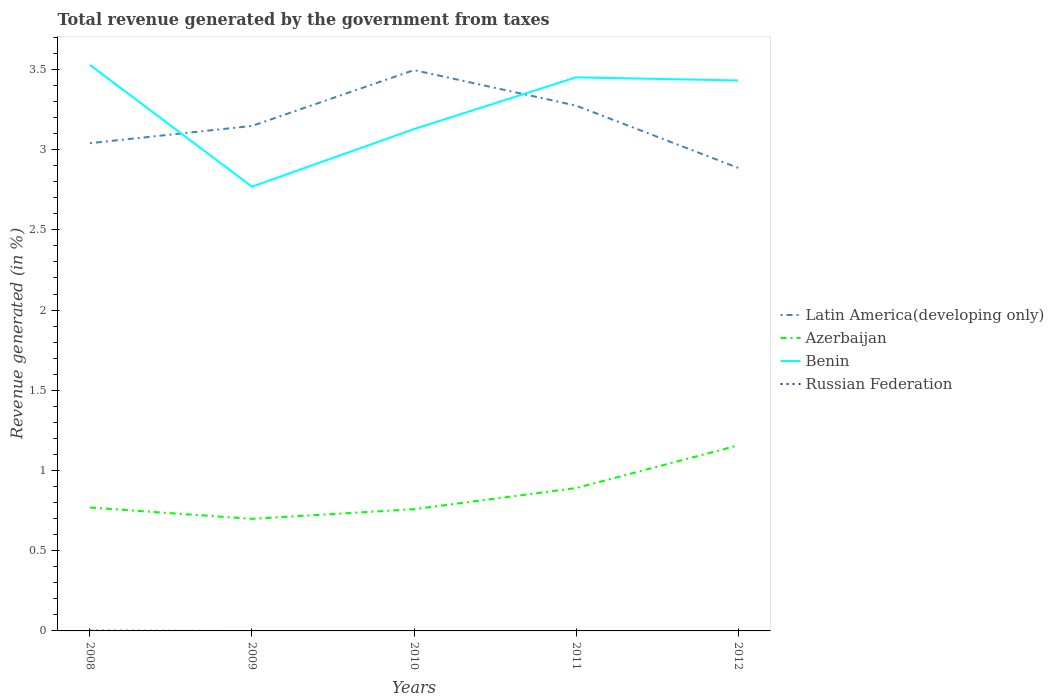How many different coloured lines are there?
Offer a very short reply. 4. Does the line corresponding to Latin America(developing only) intersect with the line corresponding to Russian Federation?
Your response must be concise. No. Is the number of lines equal to the number of legend labels?
Your answer should be compact. No. Across all years, what is the maximum total revenue generated in Azerbaijan?
Make the answer very short. 0.7. What is the total total revenue generated in Benin in the graph?
Make the answer very short. -0.66. What is the difference between the highest and the second highest total revenue generated in Azerbaijan?
Your response must be concise. 0.46. What is the difference between the highest and the lowest total revenue generated in Russian Federation?
Offer a very short reply. 1. How many lines are there?
Provide a short and direct response. 4. Are the values on the major ticks of Y-axis written in scientific E-notation?
Offer a terse response. No. Does the graph contain any zero values?
Provide a succinct answer. Yes. Where does the legend appear in the graph?
Give a very brief answer. Center right. How are the legend labels stacked?
Your response must be concise. Vertical. What is the title of the graph?
Your answer should be very brief. Total revenue generated by the government from taxes. Does "Malta" appear as one of the legend labels in the graph?
Keep it short and to the point. No. What is the label or title of the X-axis?
Your answer should be compact. Years. What is the label or title of the Y-axis?
Make the answer very short. Revenue generated (in %). What is the Revenue generated (in %) in Latin America(developing only) in 2008?
Keep it short and to the point. 3.04. What is the Revenue generated (in %) in Azerbaijan in 2008?
Your answer should be compact. 0.77. What is the Revenue generated (in %) in Benin in 2008?
Provide a short and direct response. 3.53. What is the Revenue generated (in %) in Russian Federation in 2008?
Your answer should be very brief. 0. What is the Revenue generated (in %) in Latin America(developing only) in 2009?
Ensure brevity in your answer.  3.15. What is the Revenue generated (in %) of Azerbaijan in 2009?
Make the answer very short. 0.7. What is the Revenue generated (in %) in Benin in 2009?
Provide a short and direct response. 2.77. What is the Revenue generated (in %) in Latin America(developing only) in 2010?
Make the answer very short. 3.5. What is the Revenue generated (in %) in Azerbaijan in 2010?
Provide a succinct answer. 0.76. What is the Revenue generated (in %) in Benin in 2010?
Provide a short and direct response. 3.13. What is the Revenue generated (in %) of Russian Federation in 2010?
Your answer should be compact. 0. What is the Revenue generated (in %) of Latin America(developing only) in 2011?
Make the answer very short. 3.27. What is the Revenue generated (in %) in Azerbaijan in 2011?
Your answer should be compact. 0.89. What is the Revenue generated (in %) in Benin in 2011?
Your answer should be compact. 3.45. What is the Revenue generated (in %) in Latin America(developing only) in 2012?
Make the answer very short. 2.89. What is the Revenue generated (in %) in Azerbaijan in 2012?
Give a very brief answer. 1.16. What is the Revenue generated (in %) in Benin in 2012?
Offer a terse response. 3.43. Across all years, what is the maximum Revenue generated (in %) of Latin America(developing only)?
Give a very brief answer. 3.5. Across all years, what is the maximum Revenue generated (in %) of Azerbaijan?
Provide a short and direct response. 1.16. Across all years, what is the maximum Revenue generated (in %) in Benin?
Ensure brevity in your answer.  3.53. Across all years, what is the maximum Revenue generated (in %) in Russian Federation?
Your answer should be compact. 0. Across all years, what is the minimum Revenue generated (in %) of Latin America(developing only)?
Offer a terse response. 2.89. Across all years, what is the minimum Revenue generated (in %) in Azerbaijan?
Provide a short and direct response. 0.7. Across all years, what is the minimum Revenue generated (in %) in Benin?
Your response must be concise. 2.77. Across all years, what is the minimum Revenue generated (in %) of Russian Federation?
Make the answer very short. 0. What is the total Revenue generated (in %) of Latin America(developing only) in the graph?
Keep it short and to the point. 15.84. What is the total Revenue generated (in %) of Azerbaijan in the graph?
Your answer should be compact. 4.27. What is the total Revenue generated (in %) of Benin in the graph?
Your answer should be compact. 16.31. What is the total Revenue generated (in %) of Russian Federation in the graph?
Provide a short and direct response. 0. What is the difference between the Revenue generated (in %) of Latin America(developing only) in 2008 and that in 2009?
Your response must be concise. -0.11. What is the difference between the Revenue generated (in %) of Azerbaijan in 2008 and that in 2009?
Give a very brief answer. 0.07. What is the difference between the Revenue generated (in %) of Benin in 2008 and that in 2009?
Offer a terse response. 0.76. What is the difference between the Revenue generated (in %) in Latin America(developing only) in 2008 and that in 2010?
Your answer should be compact. -0.46. What is the difference between the Revenue generated (in %) in Azerbaijan in 2008 and that in 2010?
Your answer should be compact. 0.01. What is the difference between the Revenue generated (in %) of Benin in 2008 and that in 2010?
Your answer should be compact. 0.4. What is the difference between the Revenue generated (in %) of Latin America(developing only) in 2008 and that in 2011?
Your response must be concise. -0.23. What is the difference between the Revenue generated (in %) in Azerbaijan in 2008 and that in 2011?
Offer a very short reply. -0.12. What is the difference between the Revenue generated (in %) in Benin in 2008 and that in 2011?
Your answer should be compact. 0.08. What is the difference between the Revenue generated (in %) in Latin America(developing only) in 2008 and that in 2012?
Provide a succinct answer. 0.15. What is the difference between the Revenue generated (in %) of Azerbaijan in 2008 and that in 2012?
Ensure brevity in your answer.  -0.39. What is the difference between the Revenue generated (in %) in Benin in 2008 and that in 2012?
Provide a short and direct response. 0.1. What is the difference between the Revenue generated (in %) in Latin America(developing only) in 2009 and that in 2010?
Provide a short and direct response. -0.35. What is the difference between the Revenue generated (in %) in Azerbaijan in 2009 and that in 2010?
Ensure brevity in your answer.  -0.06. What is the difference between the Revenue generated (in %) of Benin in 2009 and that in 2010?
Give a very brief answer. -0.36. What is the difference between the Revenue generated (in %) in Latin America(developing only) in 2009 and that in 2011?
Provide a succinct answer. -0.13. What is the difference between the Revenue generated (in %) of Azerbaijan in 2009 and that in 2011?
Your answer should be very brief. -0.19. What is the difference between the Revenue generated (in %) of Benin in 2009 and that in 2011?
Keep it short and to the point. -0.68. What is the difference between the Revenue generated (in %) of Latin America(developing only) in 2009 and that in 2012?
Your answer should be very brief. 0.26. What is the difference between the Revenue generated (in %) in Azerbaijan in 2009 and that in 2012?
Provide a succinct answer. -0.46. What is the difference between the Revenue generated (in %) in Benin in 2009 and that in 2012?
Offer a terse response. -0.66. What is the difference between the Revenue generated (in %) in Latin America(developing only) in 2010 and that in 2011?
Provide a succinct answer. 0.22. What is the difference between the Revenue generated (in %) in Azerbaijan in 2010 and that in 2011?
Your response must be concise. -0.13. What is the difference between the Revenue generated (in %) in Benin in 2010 and that in 2011?
Your response must be concise. -0.32. What is the difference between the Revenue generated (in %) of Latin America(developing only) in 2010 and that in 2012?
Ensure brevity in your answer.  0.61. What is the difference between the Revenue generated (in %) in Azerbaijan in 2010 and that in 2012?
Keep it short and to the point. -0.4. What is the difference between the Revenue generated (in %) in Benin in 2010 and that in 2012?
Your answer should be compact. -0.3. What is the difference between the Revenue generated (in %) of Latin America(developing only) in 2011 and that in 2012?
Offer a terse response. 0.39. What is the difference between the Revenue generated (in %) in Azerbaijan in 2011 and that in 2012?
Your answer should be compact. -0.27. What is the difference between the Revenue generated (in %) in Benin in 2011 and that in 2012?
Make the answer very short. 0.02. What is the difference between the Revenue generated (in %) in Latin America(developing only) in 2008 and the Revenue generated (in %) in Azerbaijan in 2009?
Provide a short and direct response. 2.34. What is the difference between the Revenue generated (in %) of Latin America(developing only) in 2008 and the Revenue generated (in %) of Benin in 2009?
Keep it short and to the point. 0.27. What is the difference between the Revenue generated (in %) of Azerbaijan in 2008 and the Revenue generated (in %) of Benin in 2009?
Your answer should be very brief. -2. What is the difference between the Revenue generated (in %) in Latin America(developing only) in 2008 and the Revenue generated (in %) in Azerbaijan in 2010?
Your answer should be very brief. 2.28. What is the difference between the Revenue generated (in %) in Latin America(developing only) in 2008 and the Revenue generated (in %) in Benin in 2010?
Offer a very short reply. -0.09. What is the difference between the Revenue generated (in %) in Azerbaijan in 2008 and the Revenue generated (in %) in Benin in 2010?
Your answer should be very brief. -2.36. What is the difference between the Revenue generated (in %) in Latin America(developing only) in 2008 and the Revenue generated (in %) in Azerbaijan in 2011?
Your response must be concise. 2.15. What is the difference between the Revenue generated (in %) of Latin America(developing only) in 2008 and the Revenue generated (in %) of Benin in 2011?
Your answer should be compact. -0.41. What is the difference between the Revenue generated (in %) of Azerbaijan in 2008 and the Revenue generated (in %) of Benin in 2011?
Your response must be concise. -2.68. What is the difference between the Revenue generated (in %) in Latin America(developing only) in 2008 and the Revenue generated (in %) in Azerbaijan in 2012?
Provide a succinct answer. 1.88. What is the difference between the Revenue generated (in %) in Latin America(developing only) in 2008 and the Revenue generated (in %) in Benin in 2012?
Provide a succinct answer. -0.39. What is the difference between the Revenue generated (in %) of Azerbaijan in 2008 and the Revenue generated (in %) of Benin in 2012?
Offer a very short reply. -2.66. What is the difference between the Revenue generated (in %) of Latin America(developing only) in 2009 and the Revenue generated (in %) of Azerbaijan in 2010?
Your response must be concise. 2.39. What is the difference between the Revenue generated (in %) of Latin America(developing only) in 2009 and the Revenue generated (in %) of Benin in 2010?
Offer a very short reply. 0.02. What is the difference between the Revenue generated (in %) in Azerbaijan in 2009 and the Revenue generated (in %) in Benin in 2010?
Your answer should be very brief. -2.43. What is the difference between the Revenue generated (in %) in Latin America(developing only) in 2009 and the Revenue generated (in %) in Azerbaijan in 2011?
Give a very brief answer. 2.26. What is the difference between the Revenue generated (in %) of Latin America(developing only) in 2009 and the Revenue generated (in %) of Benin in 2011?
Keep it short and to the point. -0.3. What is the difference between the Revenue generated (in %) of Azerbaijan in 2009 and the Revenue generated (in %) of Benin in 2011?
Make the answer very short. -2.75. What is the difference between the Revenue generated (in %) in Latin America(developing only) in 2009 and the Revenue generated (in %) in Azerbaijan in 2012?
Provide a succinct answer. 1.99. What is the difference between the Revenue generated (in %) of Latin America(developing only) in 2009 and the Revenue generated (in %) of Benin in 2012?
Offer a terse response. -0.28. What is the difference between the Revenue generated (in %) in Azerbaijan in 2009 and the Revenue generated (in %) in Benin in 2012?
Ensure brevity in your answer.  -2.73. What is the difference between the Revenue generated (in %) in Latin America(developing only) in 2010 and the Revenue generated (in %) in Azerbaijan in 2011?
Keep it short and to the point. 2.61. What is the difference between the Revenue generated (in %) in Latin America(developing only) in 2010 and the Revenue generated (in %) in Benin in 2011?
Your answer should be compact. 0.05. What is the difference between the Revenue generated (in %) of Azerbaijan in 2010 and the Revenue generated (in %) of Benin in 2011?
Provide a succinct answer. -2.69. What is the difference between the Revenue generated (in %) of Latin America(developing only) in 2010 and the Revenue generated (in %) of Azerbaijan in 2012?
Make the answer very short. 2.34. What is the difference between the Revenue generated (in %) of Latin America(developing only) in 2010 and the Revenue generated (in %) of Benin in 2012?
Provide a succinct answer. 0.06. What is the difference between the Revenue generated (in %) in Azerbaijan in 2010 and the Revenue generated (in %) in Benin in 2012?
Keep it short and to the point. -2.67. What is the difference between the Revenue generated (in %) of Latin America(developing only) in 2011 and the Revenue generated (in %) of Azerbaijan in 2012?
Give a very brief answer. 2.12. What is the difference between the Revenue generated (in %) of Latin America(developing only) in 2011 and the Revenue generated (in %) of Benin in 2012?
Your response must be concise. -0.16. What is the difference between the Revenue generated (in %) of Azerbaijan in 2011 and the Revenue generated (in %) of Benin in 2012?
Provide a short and direct response. -2.54. What is the average Revenue generated (in %) of Latin America(developing only) per year?
Keep it short and to the point. 3.17. What is the average Revenue generated (in %) of Azerbaijan per year?
Provide a short and direct response. 0.85. What is the average Revenue generated (in %) of Benin per year?
Your answer should be very brief. 3.26. What is the average Revenue generated (in %) in Russian Federation per year?
Ensure brevity in your answer.  0. In the year 2008, what is the difference between the Revenue generated (in %) in Latin America(developing only) and Revenue generated (in %) in Azerbaijan?
Your answer should be compact. 2.27. In the year 2008, what is the difference between the Revenue generated (in %) in Latin America(developing only) and Revenue generated (in %) in Benin?
Your answer should be compact. -0.49. In the year 2008, what is the difference between the Revenue generated (in %) in Latin America(developing only) and Revenue generated (in %) in Russian Federation?
Your response must be concise. 3.04. In the year 2008, what is the difference between the Revenue generated (in %) of Azerbaijan and Revenue generated (in %) of Benin?
Make the answer very short. -2.76. In the year 2008, what is the difference between the Revenue generated (in %) in Azerbaijan and Revenue generated (in %) in Russian Federation?
Your response must be concise. 0.77. In the year 2008, what is the difference between the Revenue generated (in %) in Benin and Revenue generated (in %) in Russian Federation?
Offer a very short reply. 3.53. In the year 2009, what is the difference between the Revenue generated (in %) of Latin America(developing only) and Revenue generated (in %) of Azerbaijan?
Make the answer very short. 2.45. In the year 2009, what is the difference between the Revenue generated (in %) of Latin America(developing only) and Revenue generated (in %) of Benin?
Offer a terse response. 0.38. In the year 2009, what is the difference between the Revenue generated (in %) in Azerbaijan and Revenue generated (in %) in Benin?
Make the answer very short. -2.07. In the year 2010, what is the difference between the Revenue generated (in %) in Latin America(developing only) and Revenue generated (in %) in Azerbaijan?
Your answer should be very brief. 2.74. In the year 2010, what is the difference between the Revenue generated (in %) of Latin America(developing only) and Revenue generated (in %) of Benin?
Ensure brevity in your answer.  0.37. In the year 2010, what is the difference between the Revenue generated (in %) in Azerbaijan and Revenue generated (in %) in Benin?
Offer a very short reply. -2.37. In the year 2011, what is the difference between the Revenue generated (in %) in Latin America(developing only) and Revenue generated (in %) in Azerbaijan?
Provide a succinct answer. 2.38. In the year 2011, what is the difference between the Revenue generated (in %) in Latin America(developing only) and Revenue generated (in %) in Benin?
Give a very brief answer. -0.18. In the year 2011, what is the difference between the Revenue generated (in %) in Azerbaijan and Revenue generated (in %) in Benin?
Your answer should be compact. -2.56. In the year 2012, what is the difference between the Revenue generated (in %) of Latin America(developing only) and Revenue generated (in %) of Azerbaijan?
Provide a short and direct response. 1.73. In the year 2012, what is the difference between the Revenue generated (in %) of Latin America(developing only) and Revenue generated (in %) of Benin?
Keep it short and to the point. -0.54. In the year 2012, what is the difference between the Revenue generated (in %) in Azerbaijan and Revenue generated (in %) in Benin?
Ensure brevity in your answer.  -2.27. What is the ratio of the Revenue generated (in %) of Latin America(developing only) in 2008 to that in 2009?
Provide a succinct answer. 0.97. What is the ratio of the Revenue generated (in %) in Azerbaijan in 2008 to that in 2009?
Provide a short and direct response. 1.1. What is the ratio of the Revenue generated (in %) in Benin in 2008 to that in 2009?
Provide a succinct answer. 1.27. What is the ratio of the Revenue generated (in %) of Latin America(developing only) in 2008 to that in 2010?
Ensure brevity in your answer.  0.87. What is the ratio of the Revenue generated (in %) in Azerbaijan in 2008 to that in 2010?
Make the answer very short. 1.01. What is the ratio of the Revenue generated (in %) of Benin in 2008 to that in 2010?
Your answer should be very brief. 1.13. What is the ratio of the Revenue generated (in %) of Latin America(developing only) in 2008 to that in 2011?
Your answer should be very brief. 0.93. What is the ratio of the Revenue generated (in %) of Azerbaijan in 2008 to that in 2011?
Your answer should be compact. 0.86. What is the ratio of the Revenue generated (in %) of Benin in 2008 to that in 2011?
Offer a very short reply. 1.02. What is the ratio of the Revenue generated (in %) of Latin America(developing only) in 2008 to that in 2012?
Provide a succinct answer. 1.05. What is the ratio of the Revenue generated (in %) of Azerbaijan in 2008 to that in 2012?
Keep it short and to the point. 0.67. What is the ratio of the Revenue generated (in %) of Benin in 2008 to that in 2012?
Your response must be concise. 1.03. What is the ratio of the Revenue generated (in %) of Latin America(developing only) in 2009 to that in 2010?
Provide a succinct answer. 0.9. What is the ratio of the Revenue generated (in %) in Azerbaijan in 2009 to that in 2010?
Make the answer very short. 0.92. What is the ratio of the Revenue generated (in %) in Benin in 2009 to that in 2010?
Your response must be concise. 0.89. What is the ratio of the Revenue generated (in %) of Latin America(developing only) in 2009 to that in 2011?
Provide a succinct answer. 0.96. What is the ratio of the Revenue generated (in %) of Azerbaijan in 2009 to that in 2011?
Offer a very short reply. 0.78. What is the ratio of the Revenue generated (in %) in Benin in 2009 to that in 2011?
Keep it short and to the point. 0.8. What is the ratio of the Revenue generated (in %) of Latin America(developing only) in 2009 to that in 2012?
Make the answer very short. 1.09. What is the ratio of the Revenue generated (in %) of Azerbaijan in 2009 to that in 2012?
Keep it short and to the point. 0.6. What is the ratio of the Revenue generated (in %) of Benin in 2009 to that in 2012?
Your response must be concise. 0.81. What is the ratio of the Revenue generated (in %) in Latin America(developing only) in 2010 to that in 2011?
Your answer should be compact. 1.07. What is the ratio of the Revenue generated (in %) of Azerbaijan in 2010 to that in 2011?
Your answer should be very brief. 0.85. What is the ratio of the Revenue generated (in %) in Benin in 2010 to that in 2011?
Offer a terse response. 0.91. What is the ratio of the Revenue generated (in %) in Latin America(developing only) in 2010 to that in 2012?
Provide a succinct answer. 1.21. What is the ratio of the Revenue generated (in %) of Azerbaijan in 2010 to that in 2012?
Provide a succinct answer. 0.66. What is the ratio of the Revenue generated (in %) of Benin in 2010 to that in 2012?
Give a very brief answer. 0.91. What is the ratio of the Revenue generated (in %) in Latin America(developing only) in 2011 to that in 2012?
Your response must be concise. 1.13. What is the ratio of the Revenue generated (in %) of Azerbaijan in 2011 to that in 2012?
Your response must be concise. 0.77. What is the ratio of the Revenue generated (in %) of Benin in 2011 to that in 2012?
Your response must be concise. 1.01. What is the difference between the highest and the second highest Revenue generated (in %) of Latin America(developing only)?
Your response must be concise. 0.22. What is the difference between the highest and the second highest Revenue generated (in %) in Azerbaijan?
Offer a very short reply. 0.27. What is the difference between the highest and the second highest Revenue generated (in %) in Benin?
Provide a short and direct response. 0.08. What is the difference between the highest and the lowest Revenue generated (in %) in Latin America(developing only)?
Ensure brevity in your answer.  0.61. What is the difference between the highest and the lowest Revenue generated (in %) in Azerbaijan?
Provide a short and direct response. 0.46. What is the difference between the highest and the lowest Revenue generated (in %) in Benin?
Give a very brief answer. 0.76. What is the difference between the highest and the lowest Revenue generated (in %) in Russian Federation?
Provide a succinct answer. 0. 